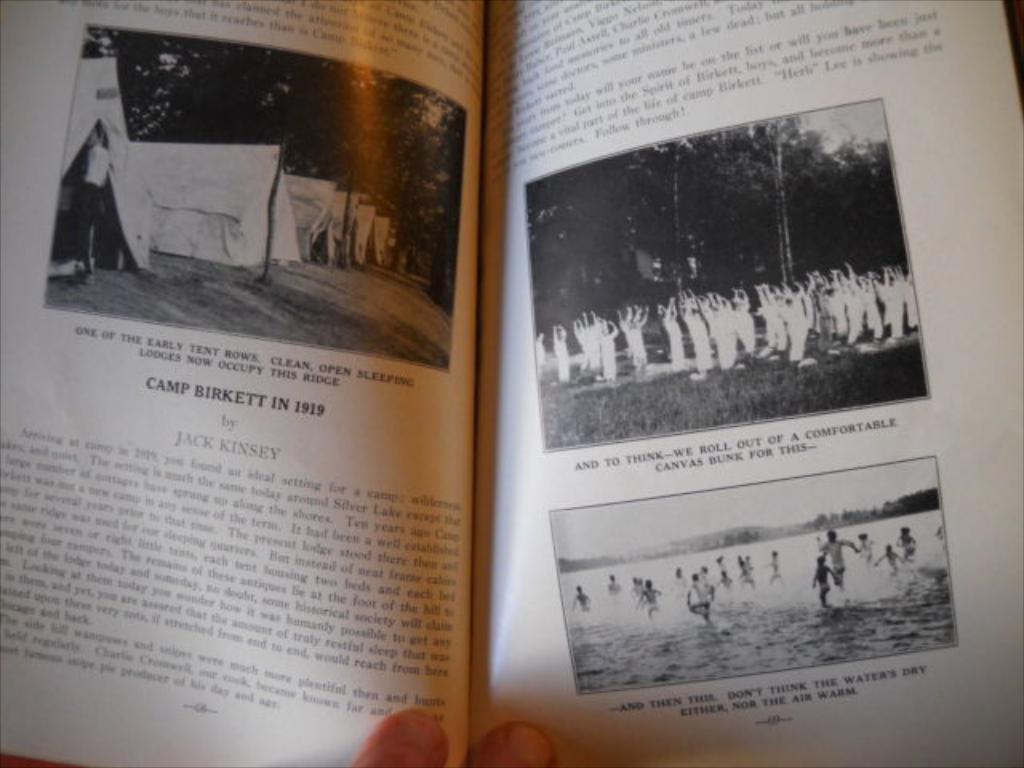Who wrote the piece on the left?
Offer a terse response. Jack kinsey. What year is the picutre of the camp from/?
Provide a succinct answer. 1919. 